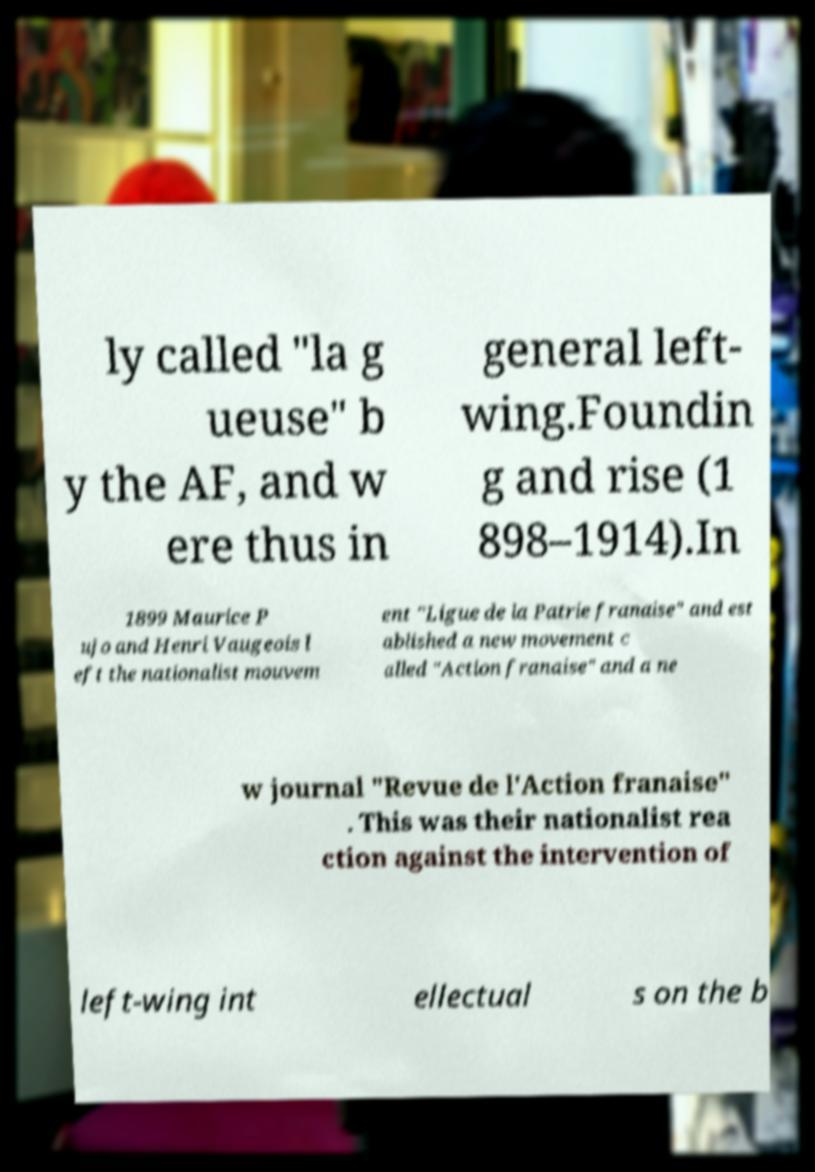I need the written content from this picture converted into text. Can you do that? ly called "la g ueuse" b y the AF, and w ere thus in general left- wing.Foundin g and rise (1 898–1914).In 1899 Maurice P ujo and Henri Vaugeois l eft the nationalist mouvem ent "Ligue de la Patrie franaise" and est ablished a new movement c alled "Action franaise" and a ne w journal "Revue de l'Action franaise" . This was their nationalist rea ction against the intervention of left-wing int ellectual s on the b 